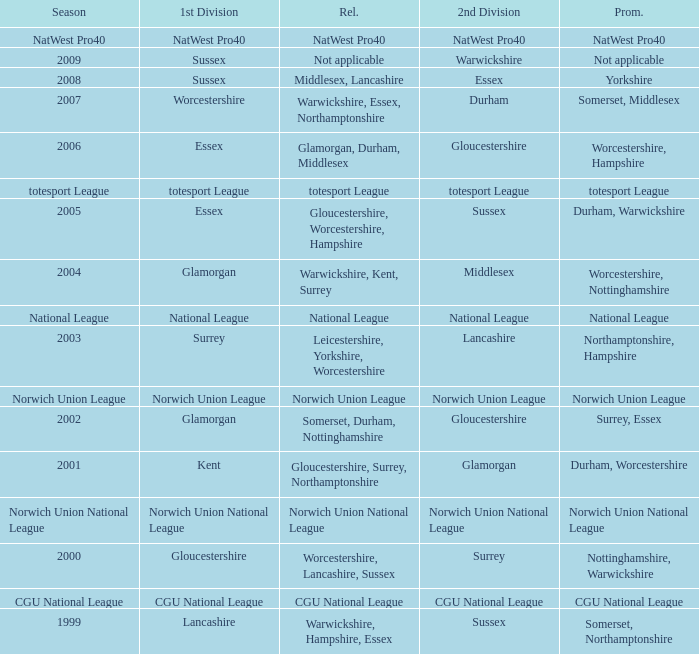What season was Norwich Union League promoted? Norwich Union League. 